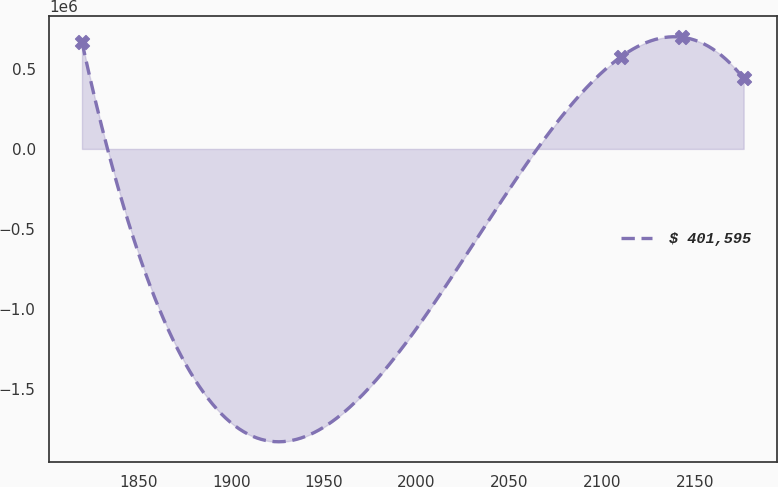Convert chart. <chart><loc_0><loc_0><loc_500><loc_500><line_chart><ecel><fcel>$ 401,595<nl><fcel>1819.56<fcel>666979<nl><fcel>2110.08<fcel>574200<nl><fcel>2143.22<fcel>697530<nl><fcel>2176.36<fcel>440040<nl></chart> 